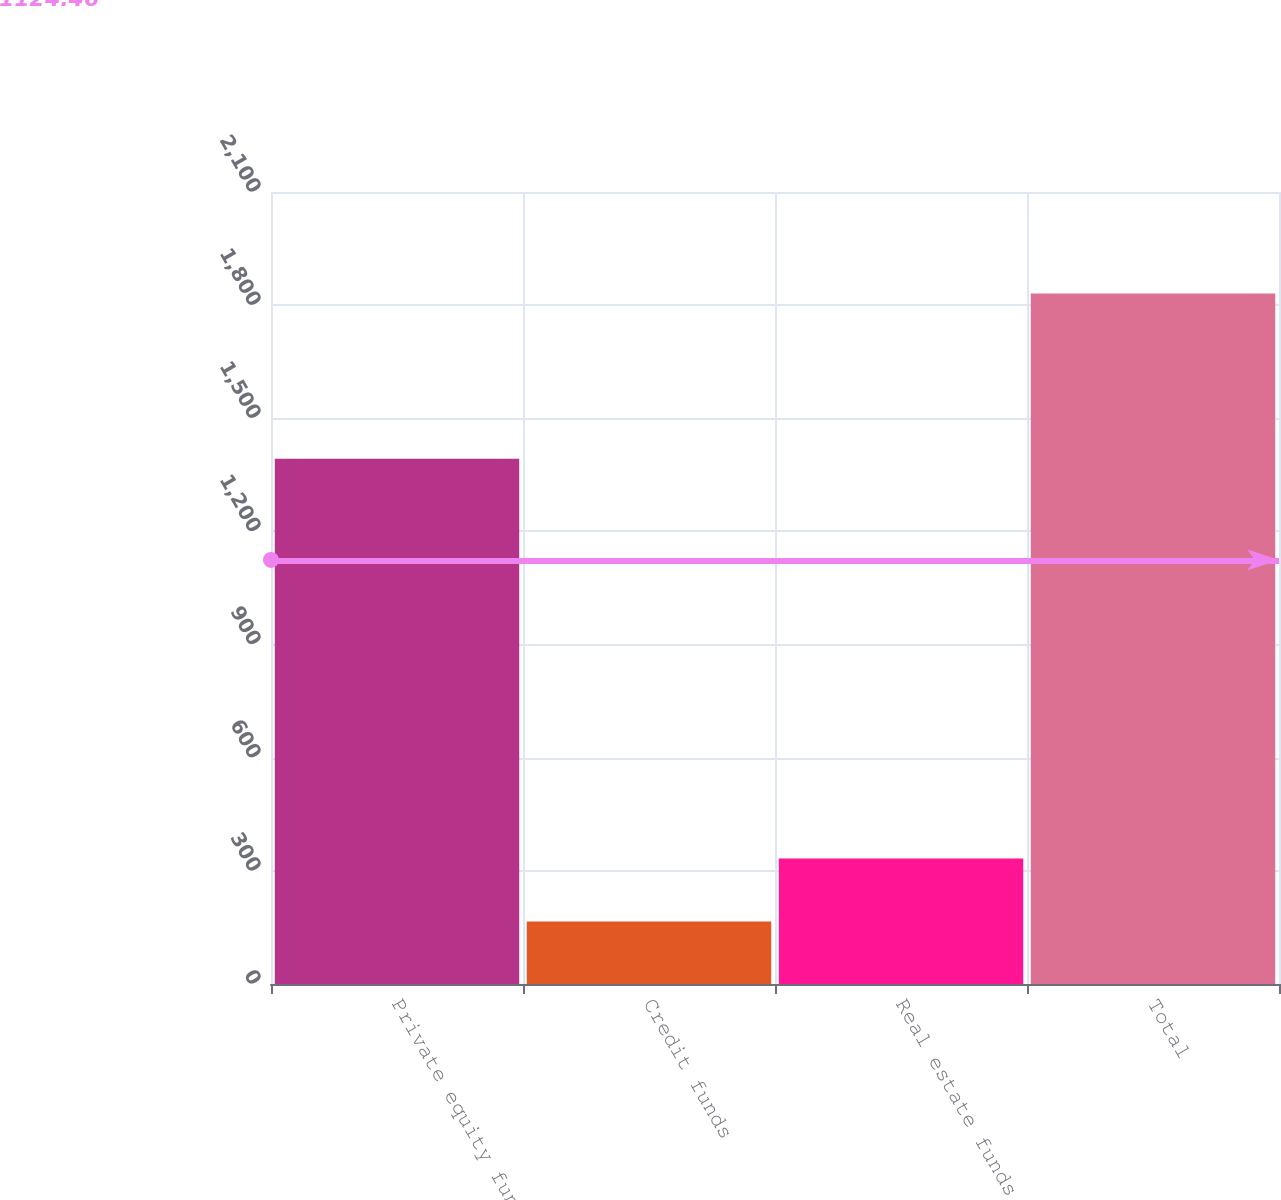Convert chart. <chart><loc_0><loc_0><loc_500><loc_500><bar_chart><fcel>Private equity funds<fcel>Credit funds<fcel>Real estate funds<fcel>Total<nl><fcel>1393<fcel>166<fcel>332.5<fcel>1831<nl></chart> 